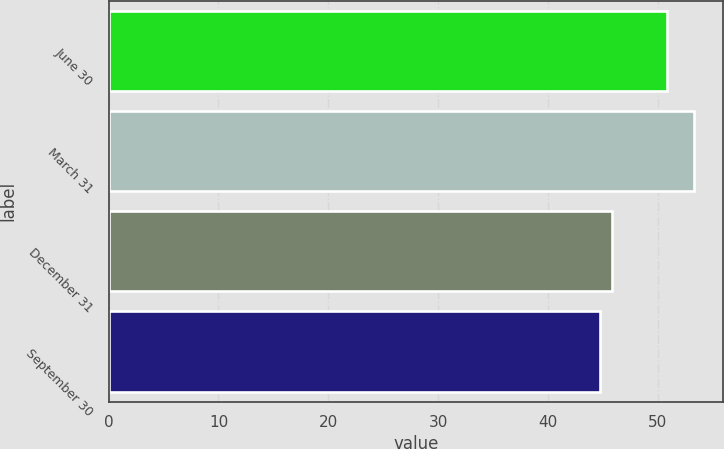Convert chart to OTSL. <chart><loc_0><loc_0><loc_500><loc_500><bar_chart><fcel>June 30<fcel>March 31<fcel>December 31<fcel>September 30<nl><fcel>50.89<fcel>53.31<fcel>45.85<fcel>44.72<nl></chart> 